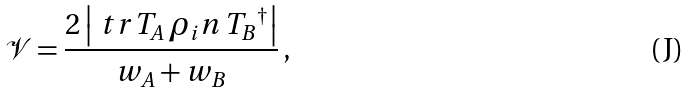Convert formula to latex. <formula><loc_0><loc_0><loc_500><loc_500>\mathcal { V } = \frac { 2 \left | \ t r { T _ { A } \, \rho _ { i } n \, { T _ { B } } ^ { \dagger } } \right | } { w _ { A } + w _ { B } } \, ,</formula> 